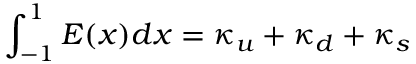<formula> <loc_0><loc_0><loc_500><loc_500>\int _ { - 1 } ^ { 1 } E ( x ) d x = \kappa _ { u } + \kappa _ { d } + \kappa _ { s }</formula> 